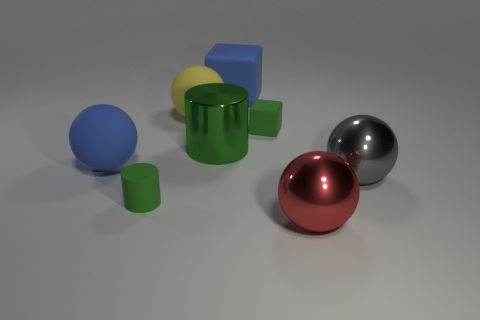Subtract all green cubes. How many cubes are left? 1 Subtract all red balls. How many balls are left? 3 Add 2 big yellow rubber balls. How many objects exist? 10 Subtract 2 blocks. How many blocks are left? 0 Subtract all red blocks. How many red cylinders are left? 0 Subtract all rubber cylinders. Subtract all green rubber cubes. How many objects are left? 6 Add 7 yellow matte objects. How many yellow matte objects are left? 8 Add 8 large red metal cylinders. How many large red metal cylinders exist? 8 Subtract 0 red cylinders. How many objects are left? 8 Subtract all cylinders. How many objects are left? 6 